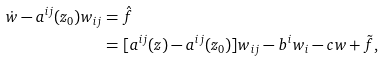<formula> <loc_0><loc_0><loc_500><loc_500>\dot { w } - a ^ { i j } ( z _ { 0 } ) w _ { i j } & = \hat { f } \\ & = [ a ^ { i j } ( z ) - a ^ { i j } ( z _ { 0 } ) ] w _ { i j } - b ^ { i } w _ { i } - c w + \tilde { f } ,</formula> 